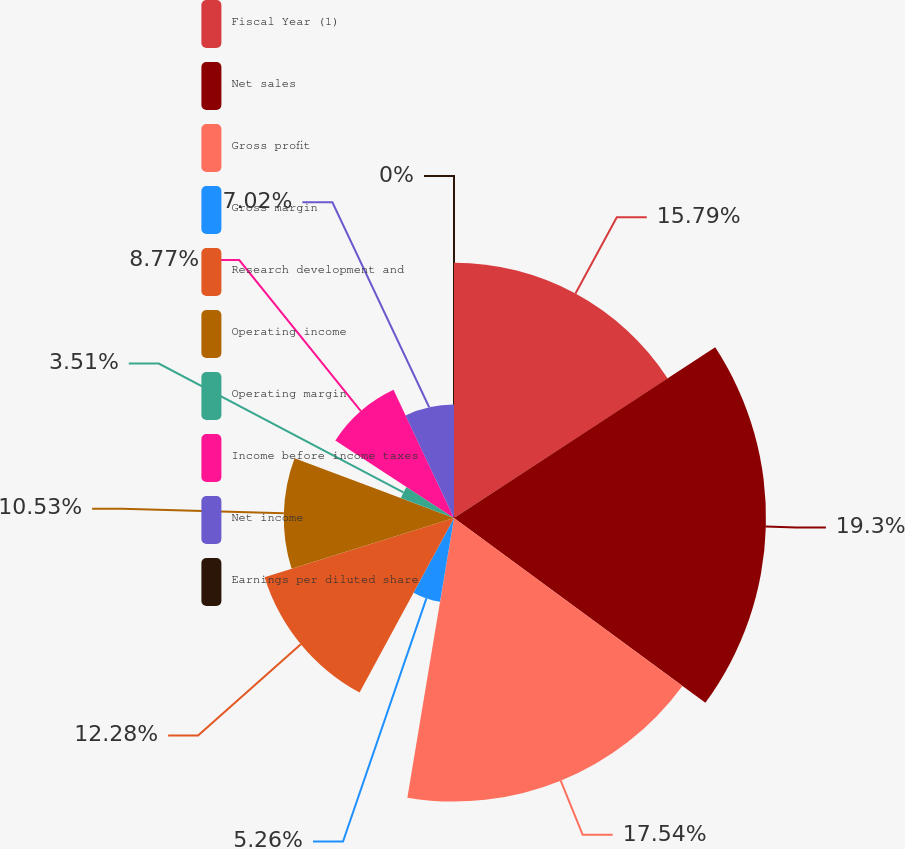Convert chart to OTSL. <chart><loc_0><loc_0><loc_500><loc_500><pie_chart><fcel>Fiscal Year (1)<fcel>Net sales<fcel>Gross profit<fcel>Gross margin<fcel>Research development and<fcel>Operating income<fcel>Operating margin<fcel>Income before income taxes<fcel>Net income<fcel>Earnings per diluted share<nl><fcel>15.79%<fcel>19.3%<fcel>17.54%<fcel>5.26%<fcel>12.28%<fcel>10.53%<fcel>3.51%<fcel>8.77%<fcel>7.02%<fcel>0.0%<nl></chart> 